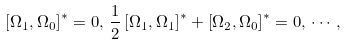<formula> <loc_0><loc_0><loc_500><loc_500>\left [ \Omega _ { 1 } , \Omega _ { 0 } \right ] ^ { * } = 0 , \, \frac { 1 } { 2 } \left [ \Omega _ { 1 } , \Omega _ { 1 } \right ] ^ { * } + \left [ \Omega _ { 2 } , \Omega _ { 0 } \right ] ^ { * } = 0 , \, \cdots ,</formula> 